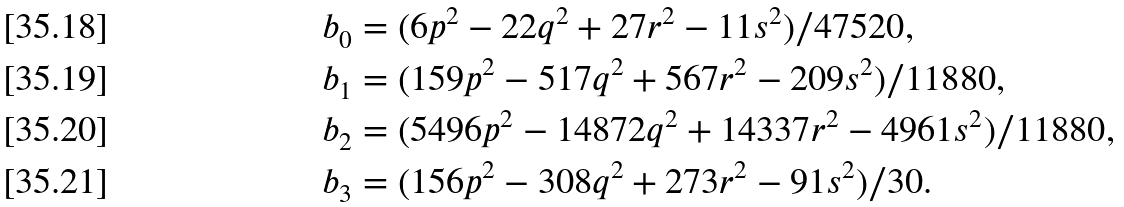Convert formula to latex. <formula><loc_0><loc_0><loc_500><loc_500>& b _ { 0 } = ( 6 p ^ { 2 } - 2 2 q ^ { 2 } + 2 7 r ^ { 2 } - 1 1 s ^ { 2 } ) / 4 7 5 2 0 , \\ & b _ { 1 } = ( 1 5 9 p ^ { 2 } - 5 1 7 q ^ { 2 } + 5 6 7 r ^ { 2 } - 2 0 9 s ^ { 2 } ) / 1 1 8 8 0 , \\ & b _ { 2 } = ( 5 4 9 6 p ^ { 2 } - 1 4 8 7 2 q ^ { 2 } + 1 4 3 3 7 r ^ { 2 } - 4 9 6 1 s ^ { 2 } ) / 1 1 8 8 0 , \\ & b _ { 3 } = ( 1 5 6 p ^ { 2 } - 3 0 8 q ^ { 2 } + 2 7 3 r ^ { 2 } - 9 1 s ^ { 2 } ) / 3 0 .</formula> 